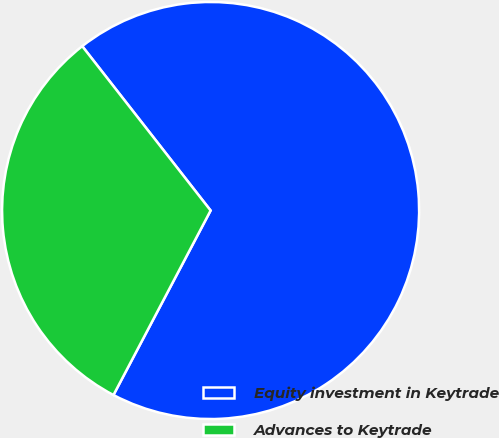Convert chart. <chart><loc_0><loc_0><loc_500><loc_500><pie_chart><fcel>Equity investment in Keytrade<fcel>Advances to Keytrade<nl><fcel>68.27%<fcel>31.73%<nl></chart> 